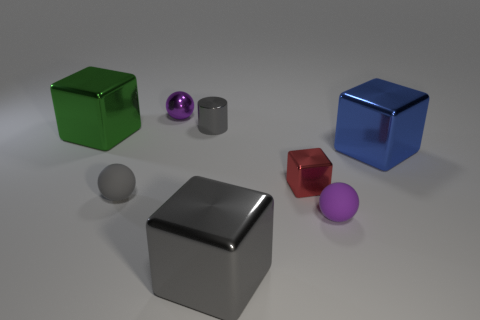Subtract all small shiny blocks. How many blocks are left? 3 Subtract all red cubes. How many cubes are left? 3 Subtract all purple blocks. Subtract all gray spheres. How many blocks are left? 4 Add 2 small gray rubber things. How many objects exist? 10 Subtract all cylinders. How many objects are left? 7 Subtract 2 purple spheres. How many objects are left? 6 Subtract all big gray things. Subtract all large green things. How many objects are left? 6 Add 7 large gray metallic objects. How many large gray metallic objects are left? 8 Add 1 brown matte spheres. How many brown matte spheres exist? 1 